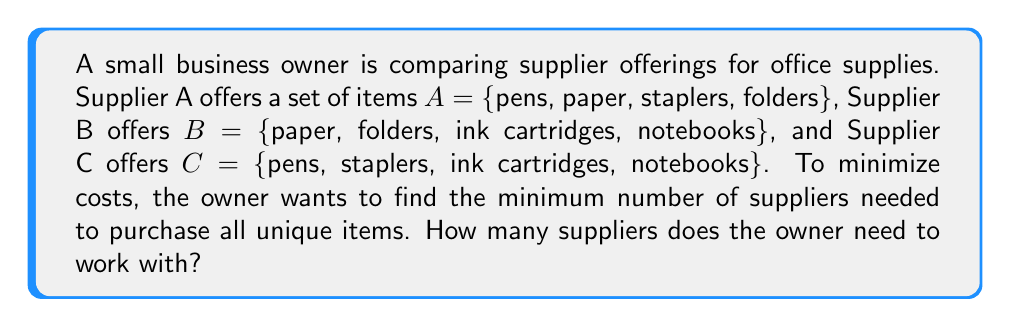Can you solve this math problem? To solve this problem, we'll use set theory concepts:

1. First, let's identify the universe of all items:
   $U = A \cup B \cup C = \{pens, paper, staplers, folders, ink cartridges, notebooks\}$

2. Now, we need to find the combination of suppliers that covers all items with the least number of suppliers. We can do this by examining different combinations:

   a) Using just one supplier:
      $|A| = 4, |B| = 4, |C| = 4$
      None of these cover all 6 items.

   b) Using two suppliers:
      $|A \cup B| = |\{pens, paper, staplers, folders, ink cartridges, notebooks\}| = 6$
      $|A \cup C| = |\{pens, paper, staplers, folders, ink cartridges, notebooks\}| = 6$
      $|B \cup C| = |\{pens, paper, staplers, folders, ink cartridges, notebooks\}| = 6$

3. We can see that any combination of two suppliers covers all items in the universe.

4. Therefore, the minimum number of suppliers needed is 2.
Answer: 2 suppliers 